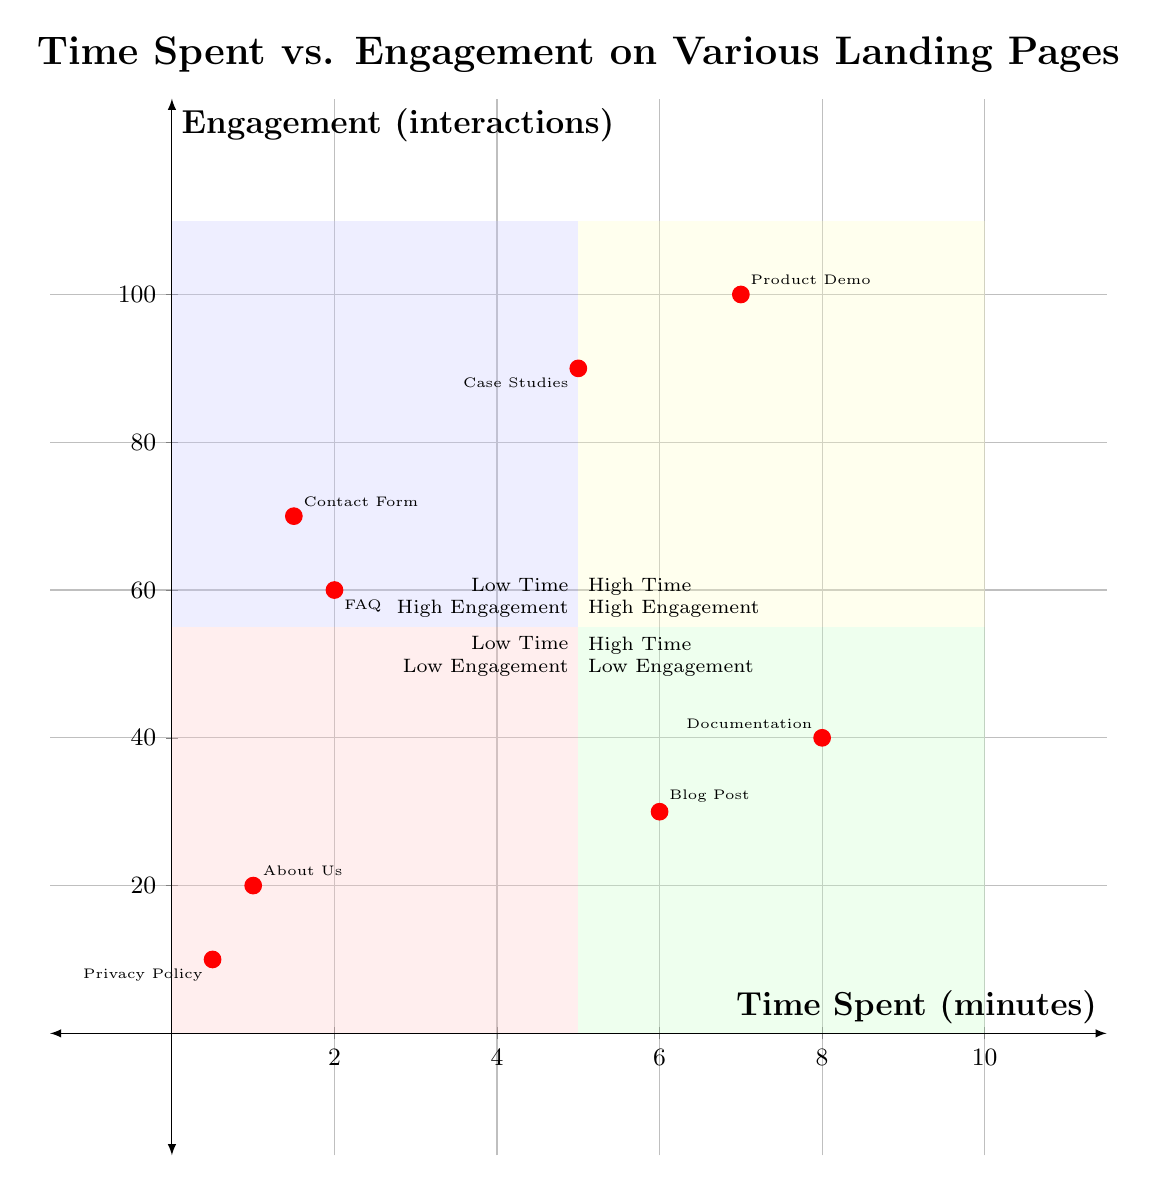What is the time spent on the "Contact Form" page? The "Contact Form" page is located in the Low Time / High Engagement quadrant. According to the data, it shows the time spent as 1.5 minutes.
Answer: 1.5 minutes How many pages are in the "High Time / High Engagement" quadrant? The "High Time / High Engagement" quadrant contains two pages: "Product Demo" and "Case Studies." Thus, the total number of pages in this quadrant is 2.
Answer: 2 Which page has the highest engagement? The "Product Demo" page is located in the High Time / High Engagement quadrant, and it shows the highest engagement value of 100 interactions compared to other pages.
Answer: Product Demo What is the engagement level of the "FAQ" page? The "FAQ" page is plotted in the Low Time / High Engagement quadrant with an engagement value of 60 interactions.
Answer: 60 interactions Which quadrant contains the "Privacy Policy" page? The "Privacy Policy" page is plotted at (0.5,10), which places it in the Low Time / Low Engagement quadrant based on the provided data.
Answer: Low Time / Low Engagement Which two pages have similar time spent but different engagement levels? The "Blog Post" and "Documentation" pages both have high time spent (6 and 8 minutes, respectively) but differ in their engagement levels (30 and 40 interactions).
Answer: Blog Post, Documentation How many minutes were spent on all pages in the "Low Time / High Engagement" quadrant? The two pages in the Low Time / High Engagement quadrant are "Contact Form" (1.5 minutes) and "FAQ" (2 minutes). The total time spent is 1.5 + 2 = 3.5 minutes.
Answer: 3.5 minutes What is the average engagement value for the pages in the "High Time / Low Engagement" quadrant? The "High Time / Low Engagement" quadrant has two pages: "Blog Post" (30 interactions) and "Documentation" (40 interactions). The average engagement is (30 + 40) / 2 = 35 interactions.
Answer: 35 interactions 